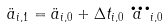<formula> <loc_0><loc_0><loc_500><loc_500>\ddot { a } _ { i , 1 } = \ddot { a } _ { i , 0 } + \Delta t _ { i , 0 } \dddot { a } _ { i , 0 }</formula> 